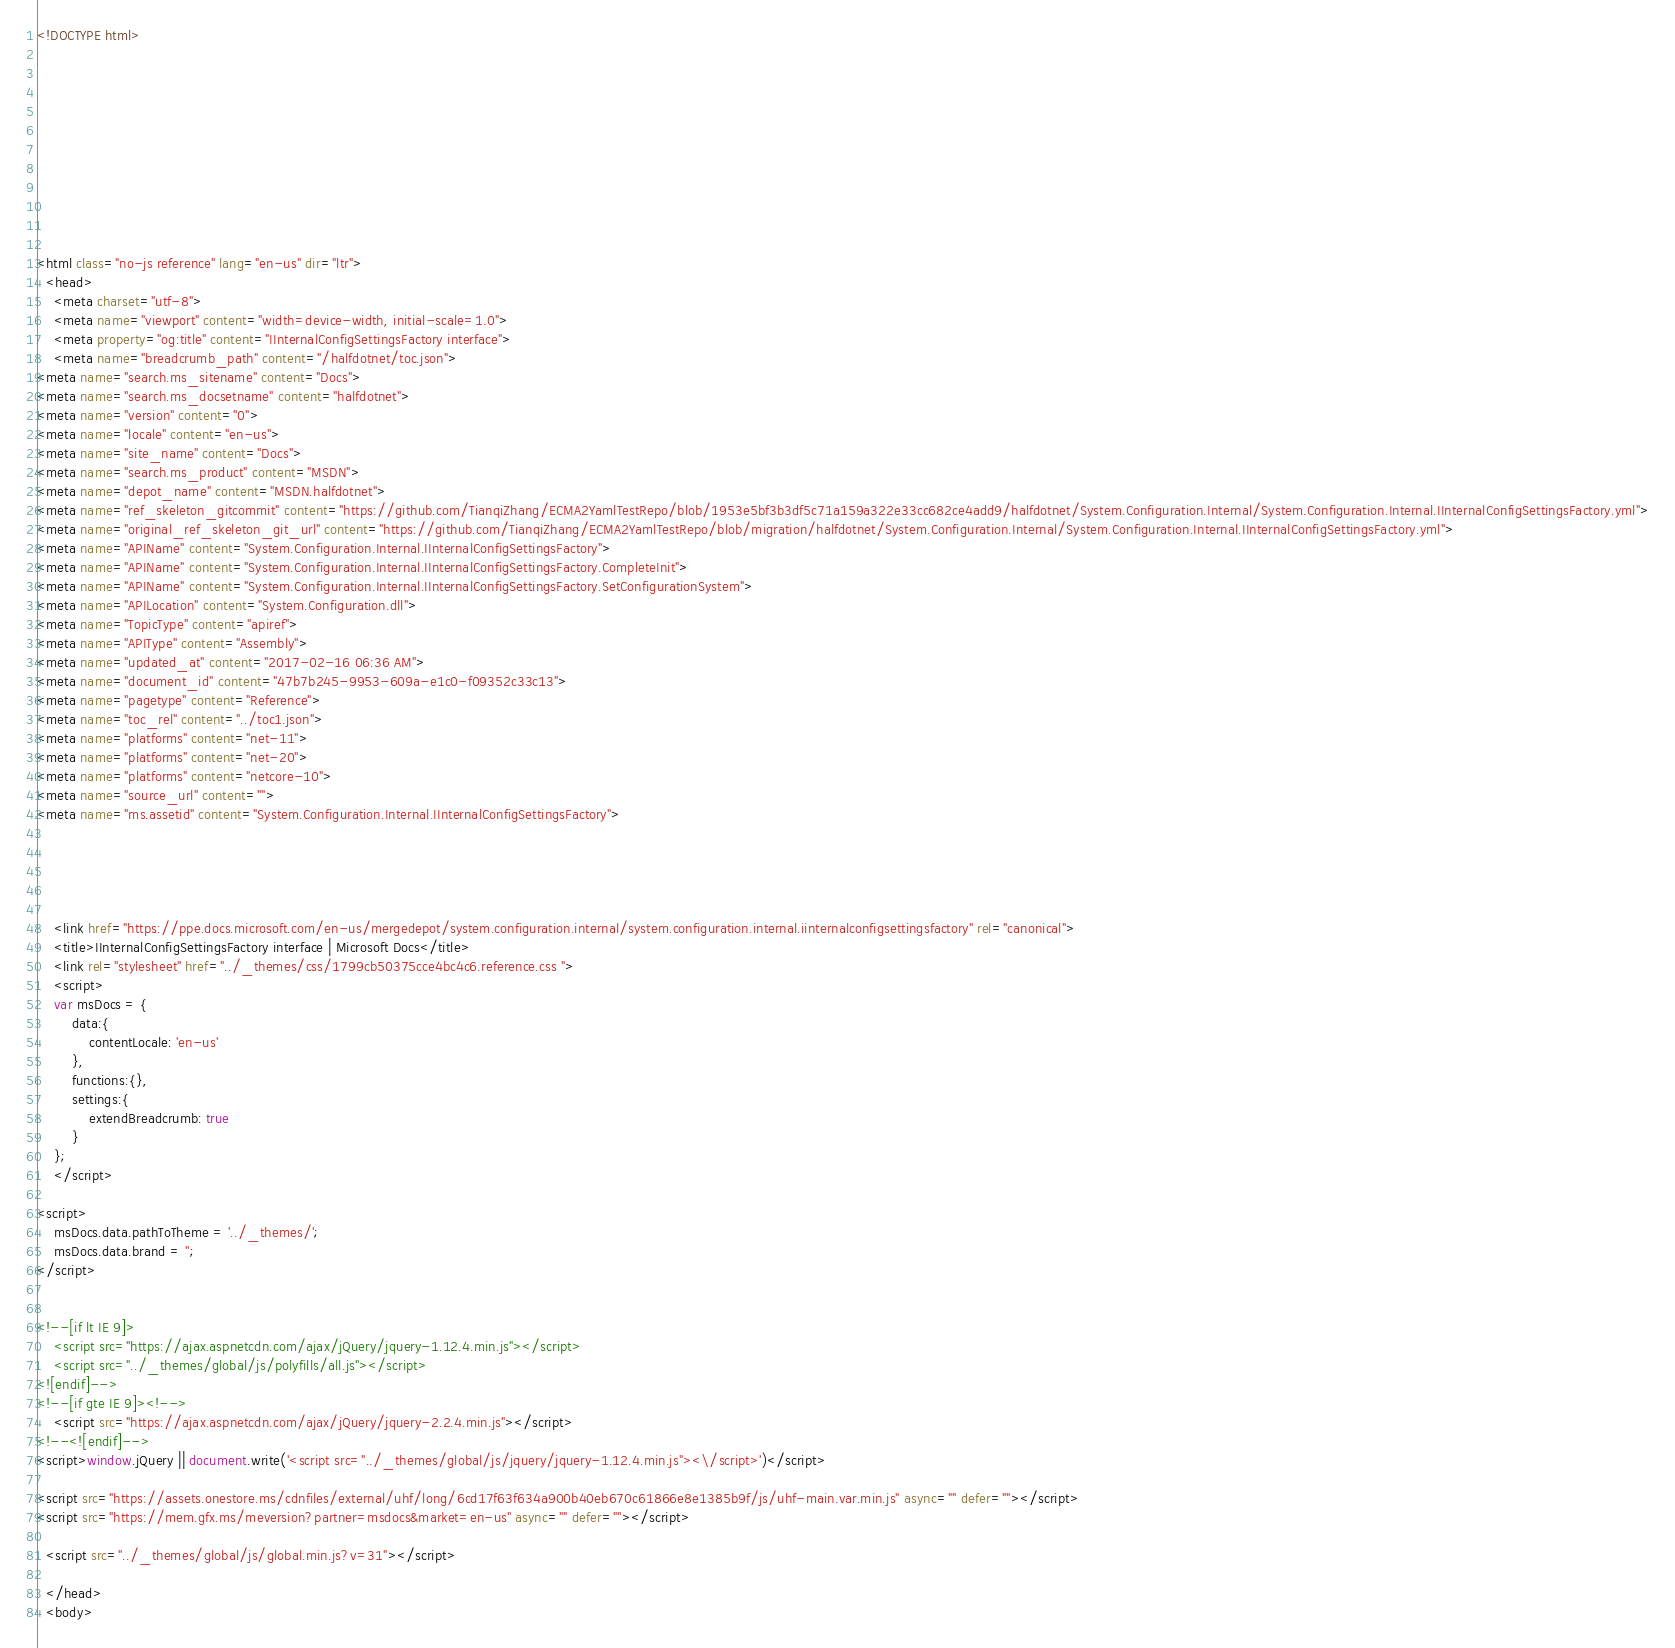<code> <loc_0><loc_0><loc_500><loc_500><_HTML_><!DOCTYPE html>



  


  


  

<html class="no-js reference" lang="en-us" dir="ltr">
  <head>
    <meta charset="utf-8">
    <meta name="viewport" content="width=device-width, initial-scale=1.0">
    <meta property="og:title" content="IInternalConfigSettingsFactory interface">
    <meta name="breadcrumb_path" content="/halfdotnet/toc.json">
<meta name="search.ms_sitename" content="Docs">
<meta name="search.ms_docsetname" content="halfdotnet">
<meta name="version" content="0">
<meta name="locale" content="en-us">
<meta name="site_name" content="Docs">
<meta name="search.ms_product" content="MSDN">
<meta name="depot_name" content="MSDN.halfdotnet">
<meta name="ref_skeleton_gitcommit" content="https://github.com/TianqiZhang/ECMA2YamlTestRepo/blob/1953e5bf3b3df5c71a159a322e33cc682ce4add9/halfdotnet/System.Configuration.Internal/System.Configuration.Internal.IInternalConfigSettingsFactory.yml">
<meta name="original_ref_skeleton_git_url" content="https://github.com/TianqiZhang/ECMA2YamlTestRepo/blob/migration/halfdotnet/System.Configuration.Internal/System.Configuration.Internal.IInternalConfigSettingsFactory.yml">
<meta name="APIName" content="System.Configuration.Internal.IInternalConfigSettingsFactory">
<meta name="APIName" content="System.Configuration.Internal.IInternalConfigSettingsFactory.CompleteInit">
<meta name="APIName" content="System.Configuration.Internal.IInternalConfigSettingsFactory.SetConfigurationSystem">
<meta name="APILocation" content="System.Configuration.dll">
<meta name="TopicType" content="apiref">
<meta name="APIType" content="Assembly">
<meta name="updated_at" content="2017-02-16 06:36 AM">
<meta name="document_id" content="47b7b245-9953-609a-e1c0-f09352c33c13">
<meta name="pagetype" content="Reference">
<meta name="toc_rel" content="../toc1.json">
<meta name="platforms" content="net-11">
<meta name="platforms" content="net-20">
<meta name="platforms" content="netcore-10">
<meta name="source_url" content="">
<meta name="ms.assetid" content="System.Configuration.Internal.IInternalConfigSettingsFactory">

    
    
      
    
    <link href="https://ppe.docs.microsoft.com/en-us/mergedepot/system.configuration.internal/system.configuration.internal.iinternalconfigsettingsfactory" rel="canonical">
    <title>IInternalConfigSettingsFactory interface | Microsoft Docs</title>
    <link rel="stylesheet" href="../_themes/css/1799cb50375cce4bc4c6.reference.css ">
    <script>
	var msDocs = {
		data:{
			contentLocale: 'en-us'
		},
		functions:{},
		settings:{
			extendBreadcrumb: true
		}
	};
	</script>

<script>
	msDocs.data.pathToTheme = '../_themes/';
	msDocs.data.brand = '';
</script>


<!--[if lt IE 9]>
	<script src="https://ajax.aspnetcdn.com/ajax/jQuery/jquery-1.12.4.min.js"></script>
	<script src="../_themes/global/js/polyfills/all.js"></script>
<![endif]-->
<!--[if gte IE 9]><!-->
	<script src="https://ajax.aspnetcdn.com/ajax/jQuery/jquery-2.2.4.min.js"></script>
<!--<![endif]-->
<script>window.jQuery || document.write('<script src="../_themes/global/js/jquery/jquery-1.12.4.min.js"><\/script>')</script>

<script src="https://assets.onestore.ms/cdnfiles/external/uhf/long/6cd17f63f634a900b40eb670c61866e8e1385b9f/js/uhf-main.var.min.js" async="" defer=""></script>
<script src="https://mem.gfx.ms/meversion?partner=msdocs&market=en-us" async="" defer=""></script>

  <script src="../_themes/global/js/global.min.js?v=31"></script>

  </head>
  <body>


</code> 